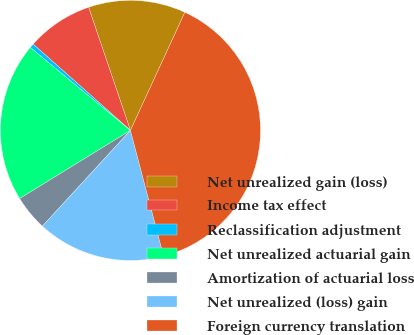Convert chart to OTSL. <chart><loc_0><loc_0><loc_500><loc_500><pie_chart><fcel>Net unrealized gain (loss)<fcel>Income tax effect<fcel>Reclassification adjustment<fcel>Net unrealized actuarial gain<fcel>Amortization of actuarial loss<fcel>Net unrealized (loss) gain<fcel>Foreign currency translation<nl><fcel>12.09%<fcel>8.24%<fcel>0.54%<fcel>19.79%<fcel>4.39%<fcel>15.94%<fcel>39.03%<nl></chart> 